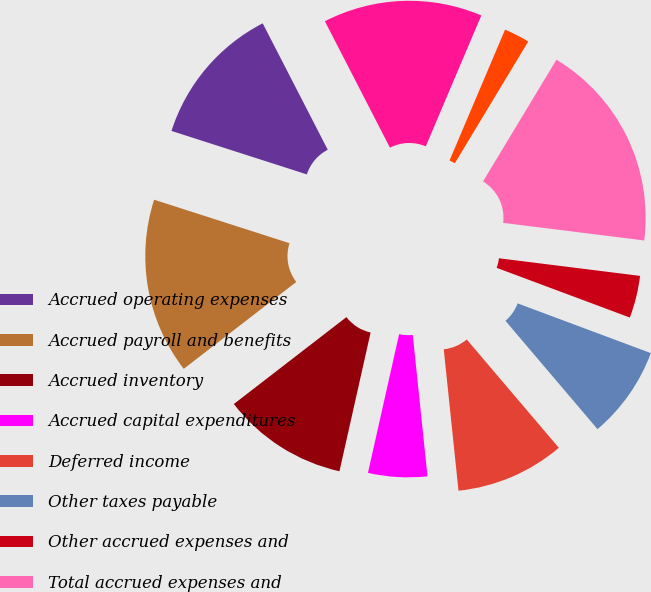Convert chart. <chart><loc_0><loc_0><loc_500><loc_500><pie_chart><fcel>Accrued operating expenses<fcel>Accrued payroll and benefits<fcel>Accrued inventory<fcel>Accrued capital expenditures<fcel>Deferred income<fcel>Other taxes payable<fcel>Other accrued expenses and<fcel>Total accrued expenses and<fcel>Capital lease obligations<fcel>Deferred rent obligations<nl><fcel>12.49%<fcel>15.41%<fcel>11.02%<fcel>5.17%<fcel>9.56%<fcel>8.1%<fcel>3.71%<fcel>18.34%<fcel>2.25%<fcel>13.95%<nl></chart> 